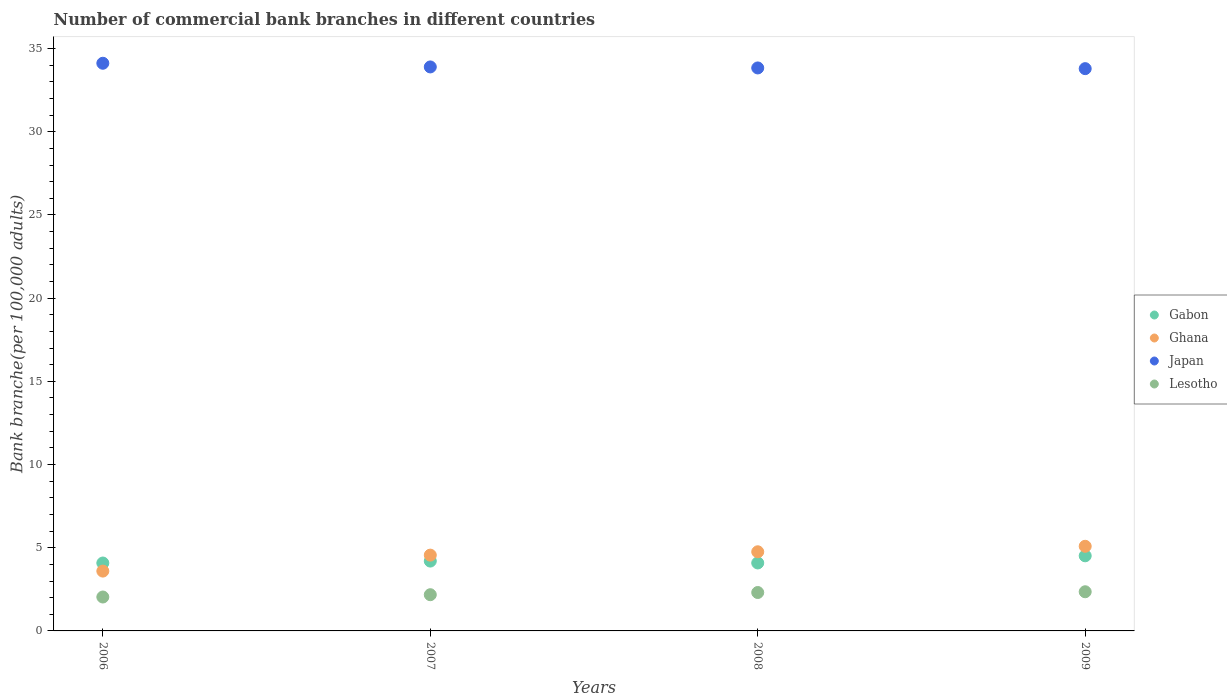What is the number of commercial bank branches in Lesotho in 2009?
Provide a short and direct response. 2.35. Across all years, what is the maximum number of commercial bank branches in Ghana?
Ensure brevity in your answer.  5.09. Across all years, what is the minimum number of commercial bank branches in Gabon?
Provide a succinct answer. 4.08. In which year was the number of commercial bank branches in Ghana maximum?
Make the answer very short. 2009. What is the total number of commercial bank branches in Japan in the graph?
Ensure brevity in your answer.  135.63. What is the difference between the number of commercial bank branches in Gabon in 2007 and that in 2009?
Keep it short and to the point. -0.32. What is the difference between the number of commercial bank branches in Lesotho in 2009 and the number of commercial bank branches in Gabon in 2008?
Offer a terse response. -1.73. What is the average number of commercial bank branches in Lesotho per year?
Offer a very short reply. 2.22. In the year 2007, what is the difference between the number of commercial bank branches in Japan and number of commercial bank branches in Ghana?
Provide a succinct answer. 29.34. In how many years, is the number of commercial bank branches in Lesotho greater than 31?
Offer a terse response. 0. What is the ratio of the number of commercial bank branches in Japan in 2007 to that in 2009?
Your answer should be very brief. 1. Is the number of commercial bank branches in Lesotho in 2008 less than that in 2009?
Offer a very short reply. Yes. Is the difference between the number of commercial bank branches in Japan in 2007 and 2008 greater than the difference between the number of commercial bank branches in Ghana in 2007 and 2008?
Your answer should be very brief. Yes. What is the difference between the highest and the second highest number of commercial bank branches in Ghana?
Ensure brevity in your answer.  0.33. What is the difference between the highest and the lowest number of commercial bank branches in Ghana?
Provide a short and direct response. 1.49. In how many years, is the number of commercial bank branches in Lesotho greater than the average number of commercial bank branches in Lesotho taken over all years?
Your response must be concise. 2. Is the sum of the number of commercial bank branches in Japan in 2008 and 2009 greater than the maximum number of commercial bank branches in Ghana across all years?
Ensure brevity in your answer.  Yes. Is it the case that in every year, the sum of the number of commercial bank branches in Ghana and number of commercial bank branches in Japan  is greater than the sum of number of commercial bank branches in Gabon and number of commercial bank branches in Lesotho?
Offer a very short reply. Yes. Is it the case that in every year, the sum of the number of commercial bank branches in Lesotho and number of commercial bank branches in Ghana  is greater than the number of commercial bank branches in Gabon?
Your answer should be compact. Yes. Does the number of commercial bank branches in Lesotho monotonically increase over the years?
Your answer should be very brief. Yes. Is the number of commercial bank branches in Ghana strictly greater than the number of commercial bank branches in Gabon over the years?
Give a very brief answer. No. Is the number of commercial bank branches in Japan strictly less than the number of commercial bank branches in Gabon over the years?
Provide a succinct answer. No. How many dotlines are there?
Make the answer very short. 4. Are the values on the major ticks of Y-axis written in scientific E-notation?
Your response must be concise. No. Does the graph contain any zero values?
Your answer should be compact. No. How many legend labels are there?
Give a very brief answer. 4. How are the legend labels stacked?
Your answer should be very brief. Vertical. What is the title of the graph?
Your answer should be very brief. Number of commercial bank branches in different countries. Does "Virgin Islands" appear as one of the legend labels in the graph?
Provide a short and direct response. No. What is the label or title of the Y-axis?
Make the answer very short. Bank branche(per 100,0 adults). What is the Bank branche(per 100,000 adults) in Gabon in 2006?
Your response must be concise. 4.08. What is the Bank branche(per 100,000 adults) of Ghana in 2006?
Your answer should be very brief. 3.6. What is the Bank branche(per 100,000 adults) in Japan in 2006?
Offer a very short reply. 34.11. What is the Bank branche(per 100,000 adults) in Lesotho in 2006?
Keep it short and to the point. 2.04. What is the Bank branche(per 100,000 adults) of Gabon in 2007?
Provide a short and direct response. 4.2. What is the Bank branche(per 100,000 adults) of Ghana in 2007?
Provide a succinct answer. 4.55. What is the Bank branche(per 100,000 adults) of Japan in 2007?
Ensure brevity in your answer.  33.89. What is the Bank branche(per 100,000 adults) of Lesotho in 2007?
Provide a short and direct response. 2.18. What is the Bank branche(per 100,000 adults) of Gabon in 2008?
Provide a succinct answer. 4.08. What is the Bank branche(per 100,000 adults) of Ghana in 2008?
Make the answer very short. 4.76. What is the Bank branche(per 100,000 adults) in Japan in 2008?
Provide a short and direct response. 33.83. What is the Bank branche(per 100,000 adults) in Lesotho in 2008?
Ensure brevity in your answer.  2.31. What is the Bank branche(per 100,000 adults) of Gabon in 2009?
Provide a short and direct response. 4.51. What is the Bank branche(per 100,000 adults) in Ghana in 2009?
Provide a succinct answer. 5.09. What is the Bank branche(per 100,000 adults) in Japan in 2009?
Provide a succinct answer. 33.79. What is the Bank branche(per 100,000 adults) in Lesotho in 2009?
Offer a terse response. 2.35. Across all years, what is the maximum Bank branche(per 100,000 adults) in Gabon?
Provide a short and direct response. 4.51. Across all years, what is the maximum Bank branche(per 100,000 adults) of Ghana?
Ensure brevity in your answer.  5.09. Across all years, what is the maximum Bank branche(per 100,000 adults) in Japan?
Keep it short and to the point. 34.11. Across all years, what is the maximum Bank branche(per 100,000 adults) of Lesotho?
Your response must be concise. 2.35. Across all years, what is the minimum Bank branche(per 100,000 adults) in Gabon?
Provide a short and direct response. 4.08. Across all years, what is the minimum Bank branche(per 100,000 adults) in Ghana?
Provide a short and direct response. 3.6. Across all years, what is the minimum Bank branche(per 100,000 adults) in Japan?
Your response must be concise. 33.79. Across all years, what is the minimum Bank branche(per 100,000 adults) in Lesotho?
Your answer should be very brief. 2.04. What is the total Bank branche(per 100,000 adults) of Gabon in the graph?
Your answer should be compact. 16.88. What is the total Bank branche(per 100,000 adults) of Ghana in the graph?
Give a very brief answer. 17.99. What is the total Bank branche(per 100,000 adults) in Japan in the graph?
Your answer should be very brief. 135.63. What is the total Bank branche(per 100,000 adults) of Lesotho in the graph?
Your answer should be very brief. 8.88. What is the difference between the Bank branche(per 100,000 adults) of Gabon in 2006 and that in 2007?
Keep it short and to the point. -0.12. What is the difference between the Bank branche(per 100,000 adults) in Ghana in 2006 and that in 2007?
Provide a succinct answer. -0.96. What is the difference between the Bank branche(per 100,000 adults) in Japan in 2006 and that in 2007?
Make the answer very short. 0.22. What is the difference between the Bank branche(per 100,000 adults) of Lesotho in 2006 and that in 2007?
Make the answer very short. -0.14. What is the difference between the Bank branche(per 100,000 adults) in Gabon in 2006 and that in 2008?
Ensure brevity in your answer.  -0. What is the difference between the Bank branche(per 100,000 adults) of Ghana in 2006 and that in 2008?
Provide a short and direct response. -1.16. What is the difference between the Bank branche(per 100,000 adults) of Japan in 2006 and that in 2008?
Offer a terse response. 0.28. What is the difference between the Bank branche(per 100,000 adults) in Lesotho in 2006 and that in 2008?
Provide a succinct answer. -0.27. What is the difference between the Bank branche(per 100,000 adults) of Gabon in 2006 and that in 2009?
Give a very brief answer. -0.43. What is the difference between the Bank branche(per 100,000 adults) in Ghana in 2006 and that in 2009?
Provide a short and direct response. -1.49. What is the difference between the Bank branche(per 100,000 adults) of Japan in 2006 and that in 2009?
Offer a very short reply. 0.32. What is the difference between the Bank branche(per 100,000 adults) in Lesotho in 2006 and that in 2009?
Keep it short and to the point. -0.32. What is the difference between the Bank branche(per 100,000 adults) in Gabon in 2007 and that in 2008?
Make the answer very short. 0.11. What is the difference between the Bank branche(per 100,000 adults) in Ghana in 2007 and that in 2008?
Give a very brief answer. -0.2. What is the difference between the Bank branche(per 100,000 adults) of Japan in 2007 and that in 2008?
Make the answer very short. 0.06. What is the difference between the Bank branche(per 100,000 adults) in Lesotho in 2007 and that in 2008?
Offer a very short reply. -0.13. What is the difference between the Bank branche(per 100,000 adults) of Gabon in 2007 and that in 2009?
Offer a very short reply. -0.32. What is the difference between the Bank branche(per 100,000 adults) of Ghana in 2007 and that in 2009?
Keep it short and to the point. -0.53. What is the difference between the Bank branche(per 100,000 adults) in Japan in 2007 and that in 2009?
Your answer should be very brief. 0.1. What is the difference between the Bank branche(per 100,000 adults) of Lesotho in 2007 and that in 2009?
Ensure brevity in your answer.  -0.18. What is the difference between the Bank branche(per 100,000 adults) of Gabon in 2008 and that in 2009?
Keep it short and to the point. -0.43. What is the difference between the Bank branche(per 100,000 adults) of Ghana in 2008 and that in 2009?
Offer a very short reply. -0.33. What is the difference between the Bank branche(per 100,000 adults) in Japan in 2008 and that in 2009?
Provide a succinct answer. 0.04. What is the difference between the Bank branche(per 100,000 adults) in Lesotho in 2008 and that in 2009?
Ensure brevity in your answer.  -0.04. What is the difference between the Bank branche(per 100,000 adults) of Gabon in 2006 and the Bank branche(per 100,000 adults) of Ghana in 2007?
Your response must be concise. -0.47. What is the difference between the Bank branche(per 100,000 adults) of Gabon in 2006 and the Bank branche(per 100,000 adults) of Japan in 2007?
Provide a succinct answer. -29.81. What is the difference between the Bank branche(per 100,000 adults) of Gabon in 2006 and the Bank branche(per 100,000 adults) of Lesotho in 2007?
Give a very brief answer. 1.9. What is the difference between the Bank branche(per 100,000 adults) in Ghana in 2006 and the Bank branche(per 100,000 adults) in Japan in 2007?
Offer a very short reply. -30.3. What is the difference between the Bank branche(per 100,000 adults) of Ghana in 2006 and the Bank branche(per 100,000 adults) of Lesotho in 2007?
Ensure brevity in your answer.  1.42. What is the difference between the Bank branche(per 100,000 adults) in Japan in 2006 and the Bank branche(per 100,000 adults) in Lesotho in 2007?
Provide a short and direct response. 31.94. What is the difference between the Bank branche(per 100,000 adults) of Gabon in 2006 and the Bank branche(per 100,000 adults) of Ghana in 2008?
Offer a very short reply. -0.68. What is the difference between the Bank branche(per 100,000 adults) of Gabon in 2006 and the Bank branche(per 100,000 adults) of Japan in 2008?
Provide a succinct answer. -29.75. What is the difference between the Bank branche(per 100,000 adults) of Gabon in 2006 and the Bank branche(per 100,000 adults) of Lesotho in 2008?
Offer a very short reply. 1.77. What is the difference between the Bank branche(per 100,000 adults) in Ghana in 2006 and the Bank branche(per 100,000 adults) in Japan in 2008?
Offer a terse response. -30.24. What is the difference between the Bank branche(per 100,000 adults) of Ghana in 2006 and the Bank branche(per 100,000 adults) of Lesotho in 2008?
Give a very brief answer. 1.29. What is the difference between the Bank branche(per 100,000 adults) of Japan in 2006 and the Bank branche(per 100,000 adults) of Lesotho in 2008?
Provide a succinct answer. 31.81. What is the difference between the Bank branche(per 100,000 adults) in Gabon in 2006 and the Bank branche(per 100,000 adults) in Ghana in 2009?
Give a very brief answer. -1.01. What is the difference between the Bank branche(per 100,000 adults) in Gabon in 2006 and the Bank branche(per 100,000 adults) in Japan in 2009?
Ensure brevity in your answer.  -29.71. What is the difference between the Bank branche(per 100,000 adults) in Gabon in 2006 and the Bank branche(per 100,000 adults) in Lesotho in 2009?
Offer a very short reply. 1.73. What is the difference between the Bank branche(per 100,000 adults) of Ghana in 2006 and the Bank branche(per 100,000 adults) of Japan in 2009?
Make the answer very short. -30.2. What is the difference between the Bank branche(per 100,000 adults) of Ghana in 2006 and the Bank branche(per 100,000 adults) of Lesotho in 2009?
Give a very brief answer. 1.24. What is the difference between the Bank branche(per 100,000 adults) in Japan in 2006 and the Bank branche(per 100,000 adults) in Lesotho in 2009?
Provide a short and direct response. 31.76. What is the difference between the Bank branche(per 100,000 adults) in Gabon in 2007 and the Bank branche(per 100,000 adults) in Ghana in 2008?
Provide a short and direct response. -0.56. What is the difference between the Bank branche(per 100,000 adults) of Gabon in 2007 and the Bank branche(per 100,000 adults) of Japan in 2008?
Your answer should be very brief. -29.64. What is the difference between the Bank branche(per 100,000 adults) of Gabon in 2007 and the Bank branche(per 100,000 adults) of Lesotho in 2008?
Ensure brevity in your answer.  1.89. What is the difference between the Bank branche(per 100,000 adults) of Ghana in 2007 and the Bank branche(per 100,000 adults) of Japan in 2008?
Your answer should be very brief. -29.28. What is the difference between the Bank branche(per 100,000 adults) of Ghana in 2007 and the Bank branche(per 100,000 adults) of Lesotho in 2008?
Offer a very short reply. 2.25. What is the difference between the Bank branche(per 100,000 adults) in Japan in 2007 and the Bank branche(per 100,000 adults) in Lesotho in 2008?
Provide a short and direct response. 31.59. What is the difference between the Bank branche(per 100,000 adults) of Gabon in 2007 and the Bank branche(per 100,000 adults) of Ghana in 2009?
Provide a short and direct response. -0.89. What is the difference between the Bank branche(per 100,000 adults) of Gabon in 2007 and the Bank branche(per 100,000 adults) of Japan in 2009?
Ensure brevity in your answer.  -29.59. What is the difference between the Bank branche(per 100,000 adults) in Gabon in 2007 and the Bank branche(per 100,000 adults) in Lesotho in 2009?
Provide a short and direct response. 1.84. What is the difference between the Bank branche(per 100,000 adults) of Ghana in 2007 and the Bank branche(per 100,000 adults) of Japan in 2009?
Your answer should be compact. -29.24. What is the difference between the Bank branche(per 100,000 adults) of Ghana in 2007 and the Bank branche(per 100,000 adults) of Lesotho in 2009?
Give a very brief answer. 2.2. What is the difference between the Bank branche(per 100,000 adults) in Japan in 2007 and the Bank branche(per 100,000 adults) in Lesotho in 2009?
Keep it short and to the point. 31.54. What is the difference between the Bank branche(per 100,000 adults) in Gabon in 2008 and the Bank branche(per 100,000 adults) in Ghana in 2009?
Offer a very short reply. -1. What is the difference between the Bank branche(per 100,000 adults) in Gabon in 2008 and the Bank branche(per 100,000 adults) in Japan in 2009?
Your answer should be compact. -29.71. What is the difference between the Bank branche(per 100,000 adults) in Gabon in 2008 and the Bank branche(per 100,000 adults) in Lesotho in 2009?
Make the answer very short. 1.73. What is the difference between the Bank branche(per 100,000 adults) in Ghana in 2008 and the Bank branche(per 100,000 adults) in Japan in 2009?
Your answer should be compact. -29.03. What is the difference between the Bank branche(per 100,000 adults) in Ghana in 2008 and the Bank branche(per 100,000 adults) in Lesotho in 2009?
Provide a succinct answer. 2.4. What is the difference between the Bank branche(per 100,000 adults) in Japan in 2008 and the Bank branche(per 100,000 adults) in Lesotho in 2009?
Provide a succinct answer. 31.48. What is the average Bank branche(per 100,000 adults) of Gabon per year?
Provide a short and direct response. 4.22. What is the average Bank branche(per 100,000 adults) in Ghana per year?
Your response must be concise. 4.5. What is the average Bank branche(per 100,000 adults) in Japan per year?
Give a very brief answer. 33.91. What is the average Bank branche(per 100,000 adults) of Lesotho per year?
Make the answer very short. 2.22. In the year 2006, what is the difference between the Bank branche(per 100,000 adults) of Gabon and Bank branche(per 100,000 adults) of Ghana?
Offer a very short reply. 0.49. In the year 2006, what is the difference between the Bank branche(per 100,000 adults) of Gabon and Bank branche(per 100,000 adults) of Japan?
Your answer should be very brief. -30.03. In the year 2006, what is the difference between the Bank branche(per 100,000 adults) in Gabon and Bank branche(per 100,000 adults) in Lesotho?
Provide a short and direct response. 2.04. In the year 2006, what is the difference between the Bank branche(per 100,000 adults) in Ghana and Bank branche(per 100,000 adults) in Japan?
Your answer should be very brief. -30.52. In the year 2006, what is the difference between the Bank branche(per 100,000 adults) of Ghana and Bank branche(per 100,000 adults) of Lesotho?
Your answer should be compact. 1.56. In the year 2006, what is the difference between the Bank branche(per 100,000 adults) in Japan and Bank branche(per 100,000 adults) in Lesotho?
Your answer should be very brief. 32.08. In the year 2007, what is the difference between the Bank branche(per 100,000 adults) in Gabon and Bank branche(per 100,000 adults) in Ghana?
Offer a terse response. -0.36. In the year 2007, what is the difference between the Bank branche(per 100,000 adults) of Gabon and Bank branche(per 100,000 adults) of Japan?
Keep it short and to the point. -29.7. In the year 2007, what is the difference between the Bank branche(per 100,000 adults) of Gabon and Bank branche(per 100,000 adults) of Lesotho?
Keep it short and to the point. 2.02. In the year 2007, what is the difference between the Bank branche(per 100,000 adults) in Ghana and Bank branche(per 100,000 adults) in Japan?
Keep it short and to the point. -29.34. In the year 2007, what is the difference between the Bank branche(per 100,000 adults) of Ghana and Bank branche(per 100,000 adults) of Lesotho?
Give a very brief answer. 2.38. In the year 2007, what is the difference between the Bank branche(per 100,000 adults) in Japan and Bank branche(per 100,000 adults) in Lesotho?
Provide a short and direct response. 31.72. In the year 2008, what is the difference between the Bank branche(per 100,000 adults) in Gabon and Bank branche(per 100,000 adults) in Ghana?
Offer a terse response. -0.67. In the year 2008, what is the difference between the Bank branche(per 100,000 adults) of Gabon and Bank branche(per 100,000 adults) of Japan?
Your answer should be very brief. -29.75. In the year 2008, what is the difference between the Bank branche(per 100,000 adults) of Gabon and Bank branche(per 100,000 adults) of Lesotho?
Offer a terse response. 1.78. In the year 2008, what is the difference between the Bank branche(per 100,000 adults) of Ghana and Bank branche(per 100,000 adults) of Japan?
Your response must be concise. -29.08. In the year 2008, what is the difference between the Bank branche(per 100,000 adults) in Ghana and Bank branche(per 100,000 adults) in Lesotho?
Provide a succinct answer. 2.45. In the year 2008, what is the difference between the Bank branche(per 100,000 adults) of Japan and Bank branche(per 100,000 adults) of Lesotho?
Give a very brief answer. 31.52. In the year 2009, what is the difference between the Bank branche(per 100,000 adults) of Gabon and Bank branche(per 100,000 adults) of Ghana?
Keep it short and to the point. -0.57. In the year 2009, what is the difference between the Bank branche(per 100,000 adults) in Gabon and Bank branche(per 100,000 adults) in Japan?
Offer a terse response. -29.28. In the year 2009, what is the difference between the Bank branche(per 100,000 adults) in Gabon and Bank branche(per 100,000 adults) in Lesotho?
Ensure brevity in your answer.  2.16. In the year 2009, what is the difference between the Bank branche(per 100,000 adults) in Ghana and Bank branche(per 100,000 adults) in Japan?
Give a very brief answer. -28.7. In the year 2009, what is the difference between the Bank branche(per 100,000 adults) of Ghana and Bank branche(per 100,000 adults) of Lesotho?
Give a very brief answer. 2.73. In the year 2009, what is the difference between the Bank branche(per 100,000 adults) in Japan and Bank branche(per 100,000 adults) in Lesotho?
Your response must be concise. 31.44. What is the ratio of the Bank branche(per 100,000 adults) in Gabon in 2006 to that in 2007?
Provide a succinct answer. 0.97. What is the ratio of the Bank branche(per 100,000 adults) of Ghana in 2006 to that in 2007?
Make the answer very short. 0.79. What is the ratio of the Bank branche(per 100,000 adults) of Japan in 2006 to that in 2007?
Give a very brief answer. 1.01. What is the ratio of the Bank branche(per 100,000 adults) of Lesotho in 2006 to that in 2007?
Your answer should be compact. 0.94. What is the ratio of the Bank branche(per 100,000 adults) in Gabon in 2006 to that in 2008?
Offer a terse response. 1. What is the ratio of the Bank branche(per 100,000 adults) of Ghana in 2006 to that in 2008?
Give a very brief answer. 0.76. What is the ratio of the Bank branche(per 100,000 adults) in Japan in 2006 to that in 2008?
Your response must be concise. 1.01. What is the ratio of the Bank branche(per 100,000 adults) of Lesotho in 2006 to that in 2008?
Offer a terse response. 0.88. What is the ratio of the Bank branche(per 100,000 adults) in Gabon in 2006 to that in 2009?
Make the answer very short. 0.9. What is the ratio of the Bank branche(per 100,000 adults) of Ghana in 2006 to that in 2009?
Give a very brief answer. 0.71. What is the ratio of the Bank branche(per 100,000 adults) of Japan in 2006 to that in 2009?
Your answer should be very brief. 1.01. What is the ratio of the Bank branche(per 100,000 adults) in Lesotho in 2006 to that in 2009?
Your answer should be very brief. 0.87. What is the ratio of the Bank branche(per 100,000 adults) in Gabon in 2007 to that in 2008?
Provide a short and direct response. 1.03. What is the ratio of the Bank branche(per 100,000 adults) in Ghana in 2007 to that in 2008?
Offer a terse response. 0.96. What is the ratio of the Bank branche(per 100,000 adults) in Japan in 2007 to that in 2008?
Ensure brevity in your answer.  1. What is the ratio of the Bank branche(per 100,000 adults) of Lesotho in 2007 to that in 2008?
Your answer should be very brief. 0.94. What is the ratio of the Bank branche(per 100,000 adults) in Gabon in 2007 to that in 2009?
Provide a short and direct response. 0.93. What is the ratio of the Bank branche(per 100,000 adults) in Ghana in 2007 to that in 2009?
Offer a very short reply. 0.9. What is the ratio of the Bank branche(per 100,000 adults) in Lesotho in 2007 to that in 2009?
Make the answer very short. 0.92. What is the ratio of the Bank branche(per 100,000 adults) in Gabon in 2008 to that in 2009?
Offer a very short reply. 0.9. What is the ratio of the Bank branche(per 100,000 adults) in Ghana in 2008 to that in 2009?
Ensure brevity in your answer.  0.94. What is the ratio of the Bank branche(per 100,000 adults) in Japan in 2008 to that in 2009?
Keep it short and to the point. 1. What is the ratio of the Bank branche(per 100,000 adults) of Lesotho in 2008 to that in 2009?
Provide a succinct answer. 0.98. What is the difference between the highest and the second highest Bank branche(per 100,000 adults) of Gabon?
Your answer should be very brief. 0.32. What is the difference between the highest and the second highest Bank branche(per 100,000 adults) in Ghana?
Make the answer very short. 0.33. What is the difference between the highest and the second highest Bank branche(per 100,000 adults) of Japan?
Offer a very short reply. 0.22. What is the difference between the highest and the second highest Bank branche(per 100,000 adults) of Lesotho?
Ensure brevity in your answer.  0.04. What is the difference between the highest and the lowest Bank branche(per 100,000 adults) in Gabon?
Your answer should be very brief. 0.43. What is the difference between the highest and the lowest Bank branche(per 100,000 adults) in Ghana?
Offer a terse response. 1.49. What is the difference between the highest and the lowest Bank branche(per 100,000 adults) of Japan?
Keep it short and to the point. 0.32. What is the difference between the highest and the lowest Bank branche(per 100,000 adults) of Lesotho?
Give a very brief answer. 0.32. 